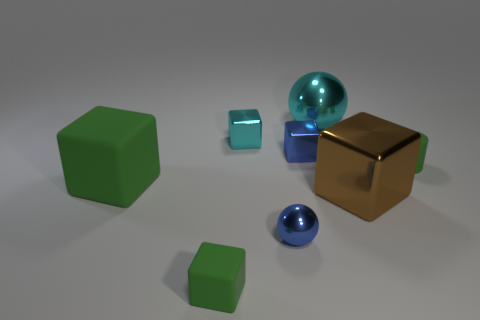Subtract all blue blocks. How many blocks are left? 4 Subtract all big metal cubes. How many cubes are left? 4 Add 1 purple cylinders. How many objects exist? 9 Subtract all yellow cubes. Subtract all gray cylinders. How many cubes are left? 5 Subtract all cubes. How many objects are left? 3 Add 8 tiny blue balls. How many tiny blue balls exist? 9 Subtract 0 red cubes. How many objects are left? 8 Subtract all large green metal cylinders. Subtract all big metal cubes. How many objects are left? 7 Add 2 cyan blocks. How many cyan blocks are left? 3 